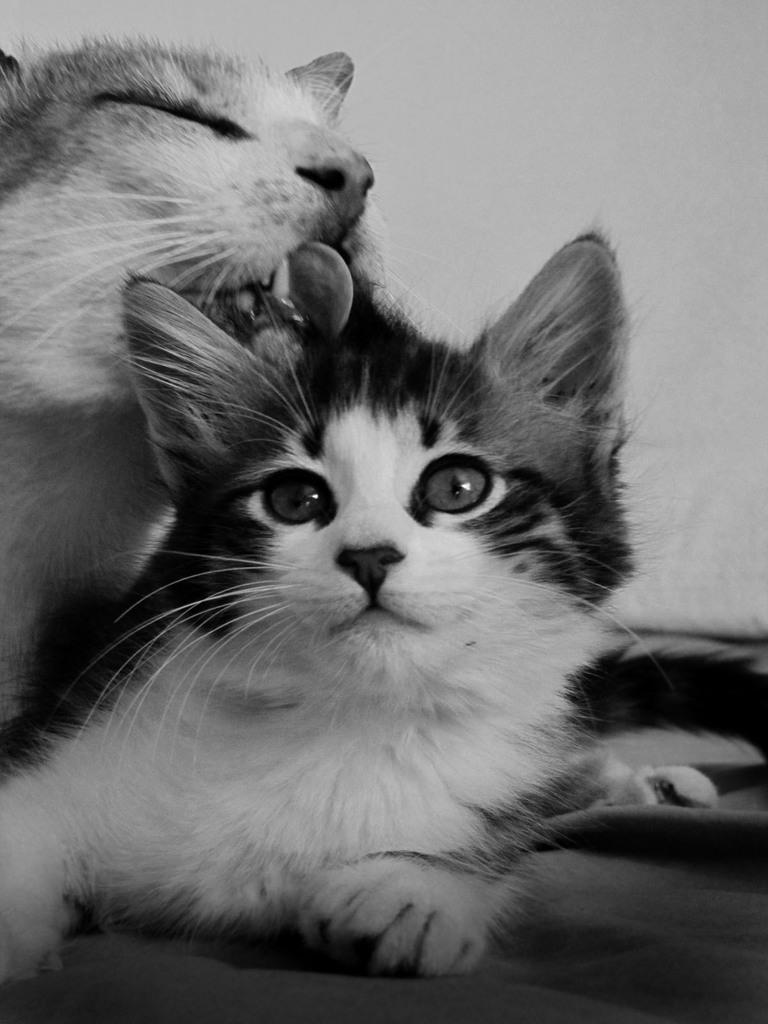How many cats are present in the image? There are two cats in the image. What can be seen in the background of the image? The background of the image is white. What type of vegetable is being carried by the porter in the image? There is no porter or vegetable present in the image; it features two cats with a white background. 